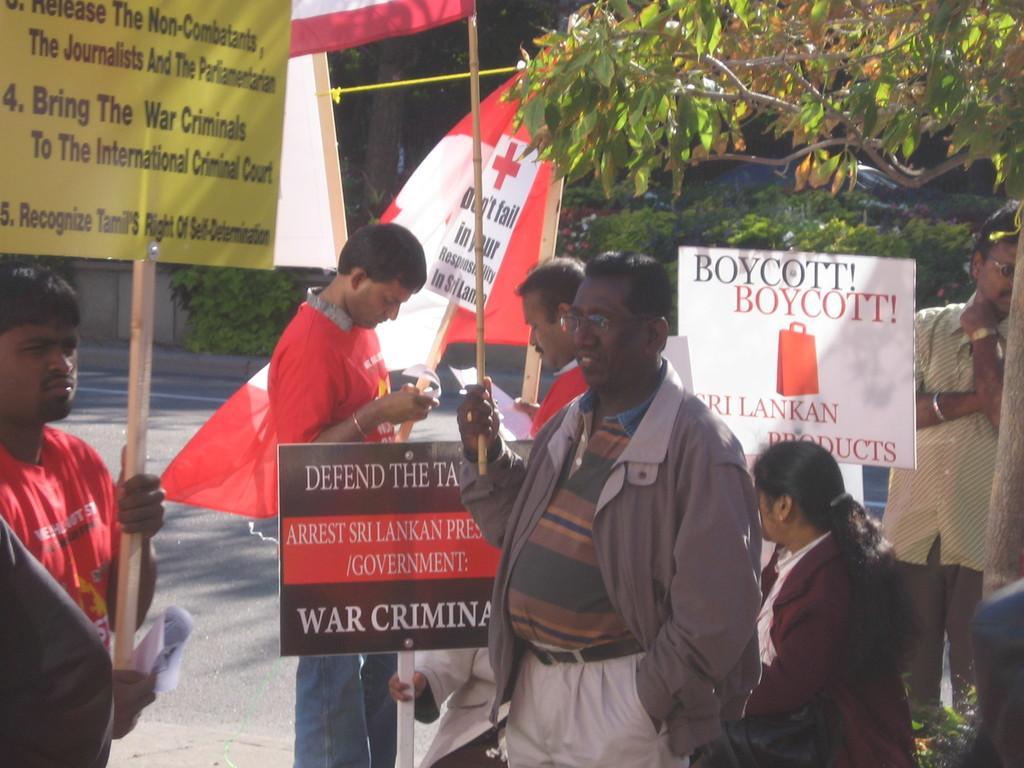What are the people in the image doing? The persons standing in the image are holding boards in their hands. What can be seen in the background of the image? There are trees in the background of the image. What is the color of the trees in the image? The trees are green in color. What type of kettle can be heard whistling in the image? There is no kettle present in the image, and therefore no sound can be heard. 